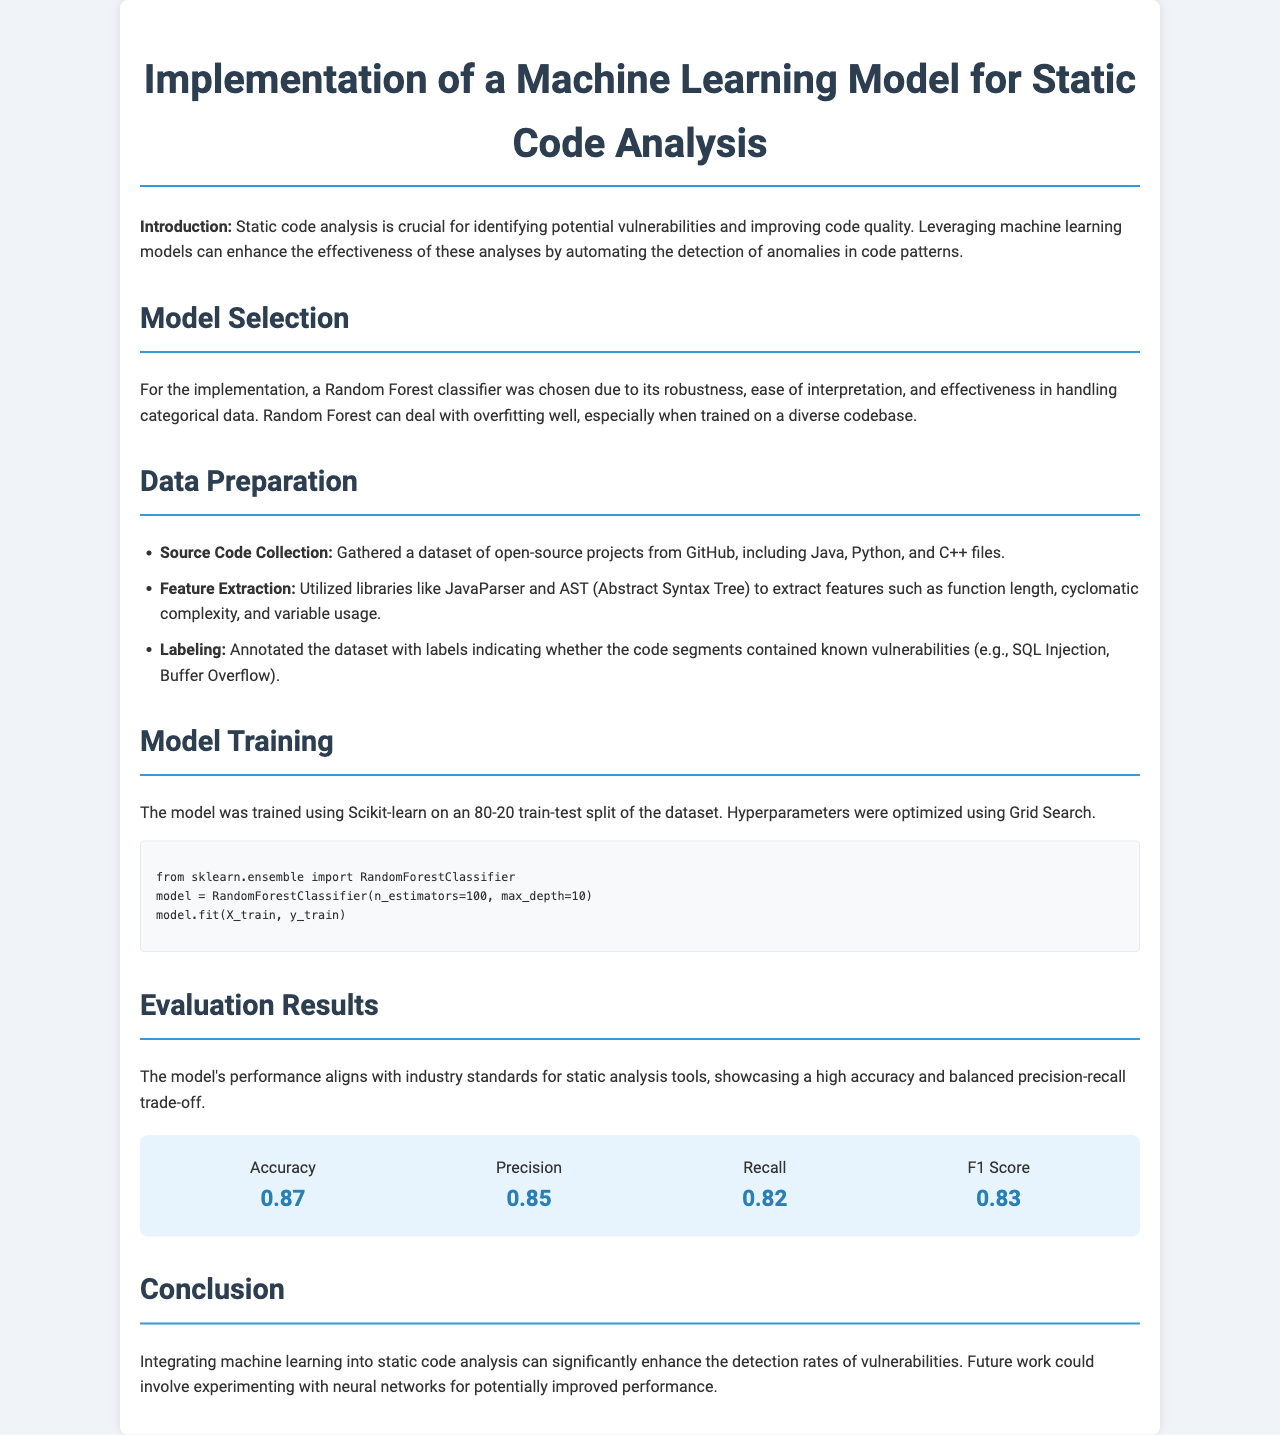What model was chosen for the implementation? The model chosen for the implementation was a Random Forest classifier due to its effectiveness in handling categorical data.
Answer: Random Forest classifier What is the accuracy of the model? The accuracy metric given in the evaluation results section indicates how well the model performed on the test data.
Answer: 0.87 How were the data labeled? The dataset was annotated with labels indicating known vulnerabilities present in the code segments.
Answer: Annotated with labels Which libraries were used for feature extraction? The document specifies that specific libraries were utilized to extract relevant features from the code.
Answer: JavaParser and AST What is the F1 Score of the model? The F1 Score is a measure derived from the precision and recall results of the model's evaluation.
Answer: 0.83 What was the training-test split ratio used for the model? The training-test split ratio describes how the dataset was divided for training and testing purposes.
Answer: 80-20 What future work is suggested in the conclusion? The conclusion section proposes an avenue for future research that may enhance the model's performance.
Answer: Experimenting with neural networks What types of programming languages were used in the dataset? The dataset consisted of various open-source projects written in multiple programming languages.
Answer: Java, Python, and C++ 